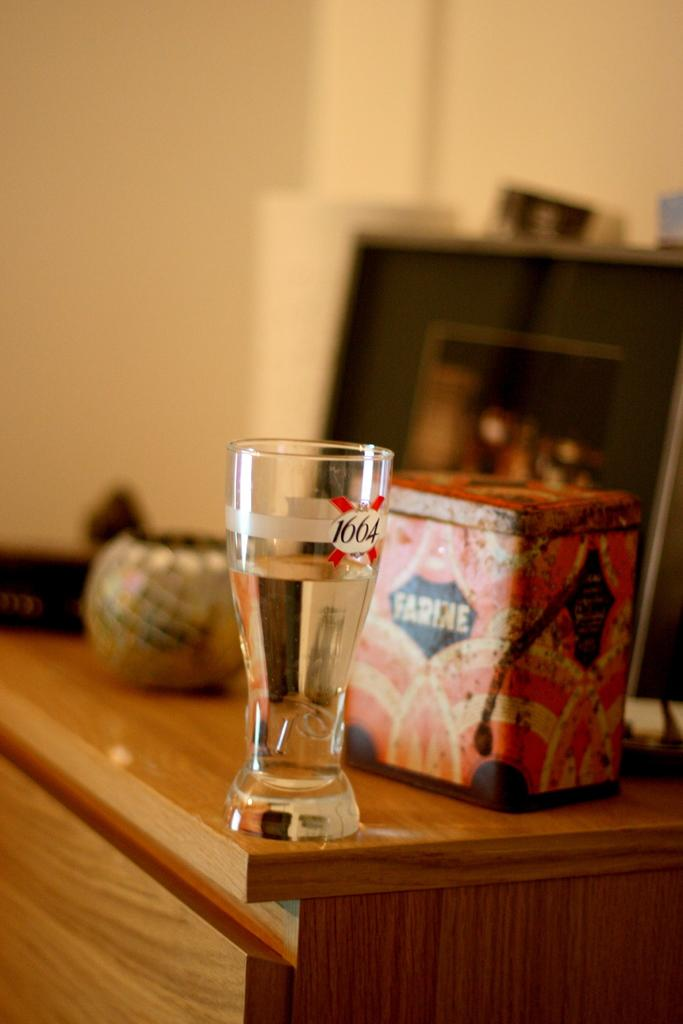What can be seen in the background of the image? There is a wall in the background of the image. What piece of furniture is present in the image? There is a table in the image. What objects are on the table? There is a box, a glass of water, and a pot on the table. How many girls are playing with the metal temper in the image? There is no mention of girls or metal temper in the image; it only features a wall, a table, and objects on the table. 